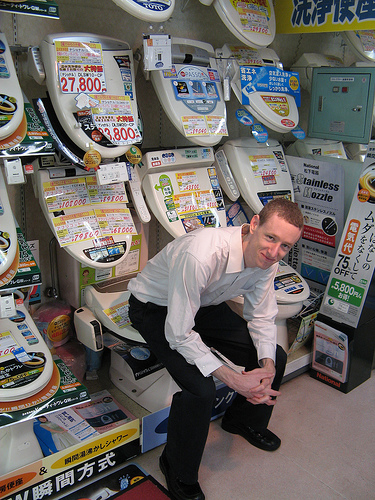Is the lady on the left or on the right? The lady is positioned on the left side of the image, adding to the dynamic of this unique shopping experience. 